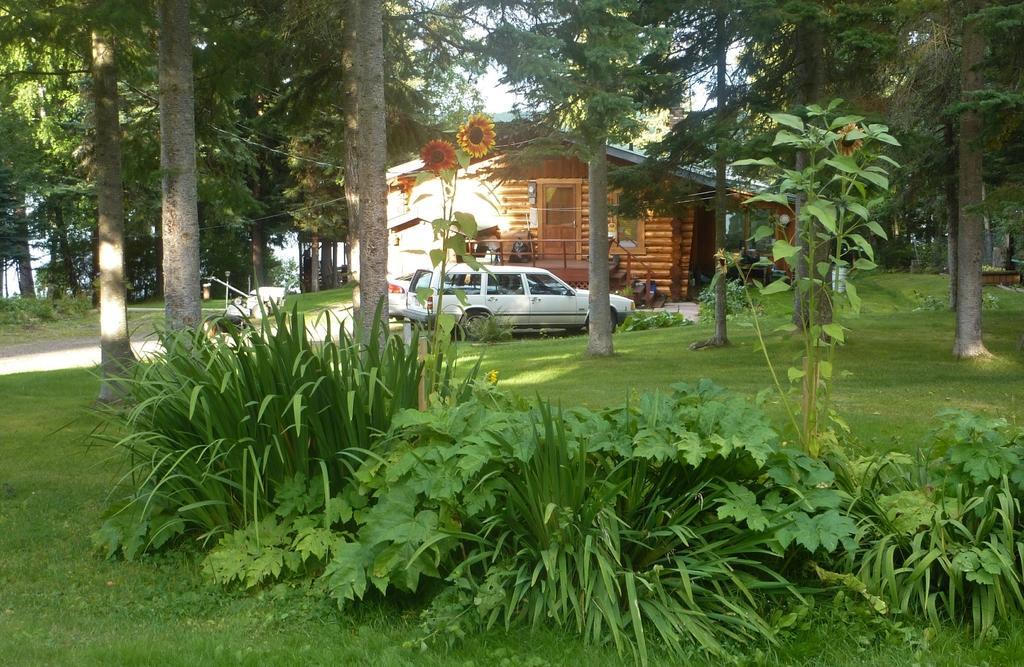Can you describe this image briefly? In this image in the foreground there are plants, trees. In the background there are building, cars, trees. This is a path. These are flowers. On the ground there is grass. 